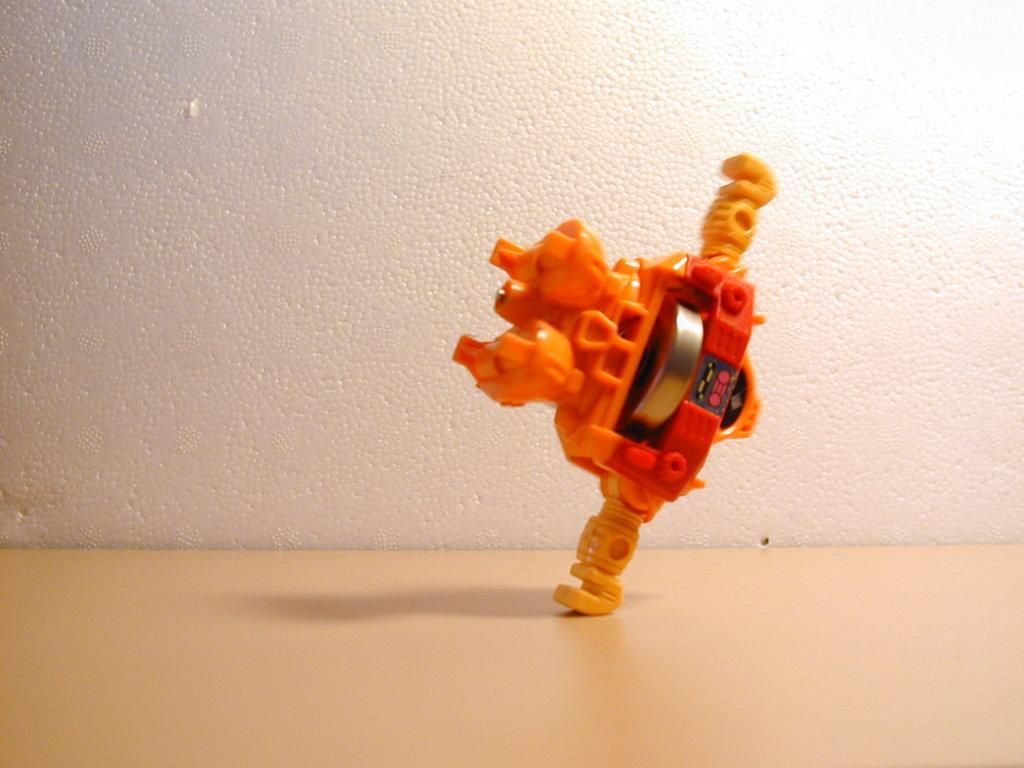How would you summarize this image in a sentence or two? In this picture I can see a orange color toy on the cream color surface. In the background I can see the wall. 